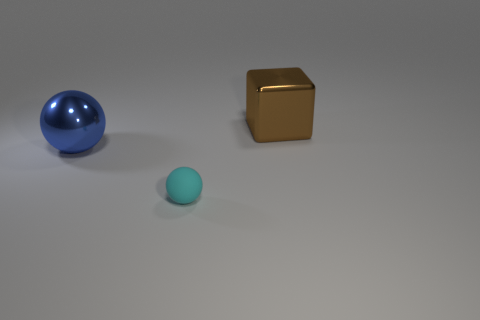Is there a red thing? no 